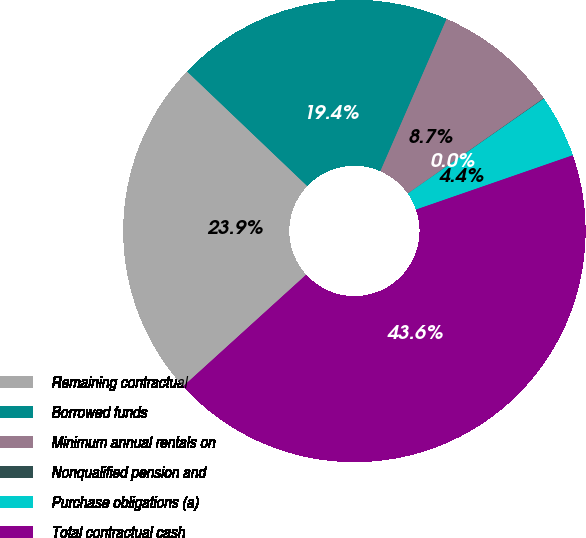Convert chart. <chart><loc_0><loc_0><loc_500><loc_500><pie_chart><fcel>Remaining contractual<fcel>Borrowed funds<fcel>Minimum annual rentals on<fcel>Nonqualified pension and<fcel>Purchase obligations (a)<fcel>Total contractual cash<nl><fcel>23.85%<fcel>19.41%<fcel>8.74%<fcel>0.03%<fcel>4.39%<fcel>43.58%<nl></chart> 